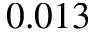<formula> <loc_0><loc_0><loc_500><loc_500>0 . 0 1 3</formula> 